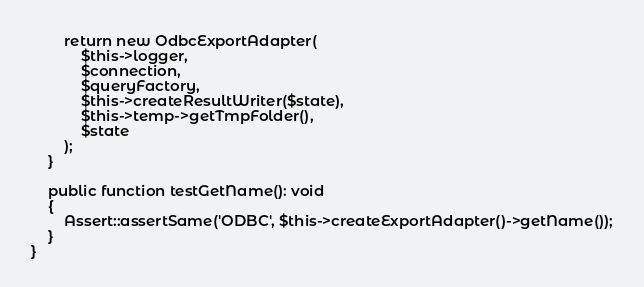<code> <loc_0><loc_0><loc_500><loc_500><_PHP_>        return new OdbcExportAdapter(
            $this->logger,
            $connection,
            $queryFactory,
            $this->createResultWriter($state),
            $this->temp->getTmpFolder(),
            $state
        );
    }

    public function testGetName(): void
    {
        Assert::assertSame('ODBC', $this->createExportAdapter()->getName());
    }
}
</code> 